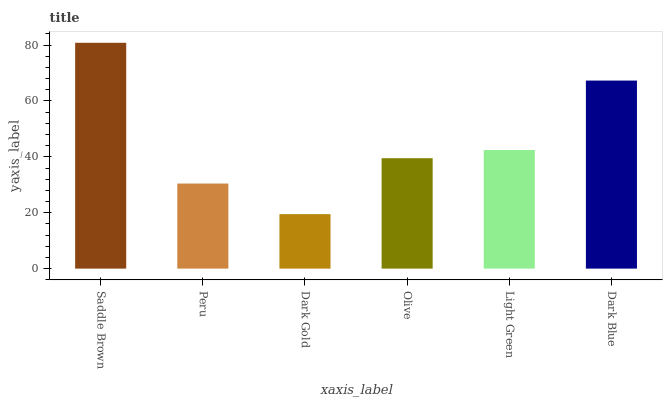Is Dark Gold the minimum?
Answer yes or no. Yes. Is Saddle Brown the maximum?
Answer yes or no. Yes. Is Peru the minimum?
Answer yes or no. No. Is Peru the maximum?
Answer yes or no. No. Is Saddle Brown greater than Peru?
Answer yes or no. Yes. Is Peru less than Saddle Brown?
Answer yes or no. Yes. Is Peru greater than Saddle Brown?
Answer yes or no. No. Is Saddle Brown less than Peru?
Answer yes or no. No. Is Light Green the high median?
Answer yes or no. Yes. Is Olive the low median?
Answer yes or no. Yes. Is Dark Blue the high median?
Answer yes or no. No. Is Peru the low median?
Answer yes or no. No. 